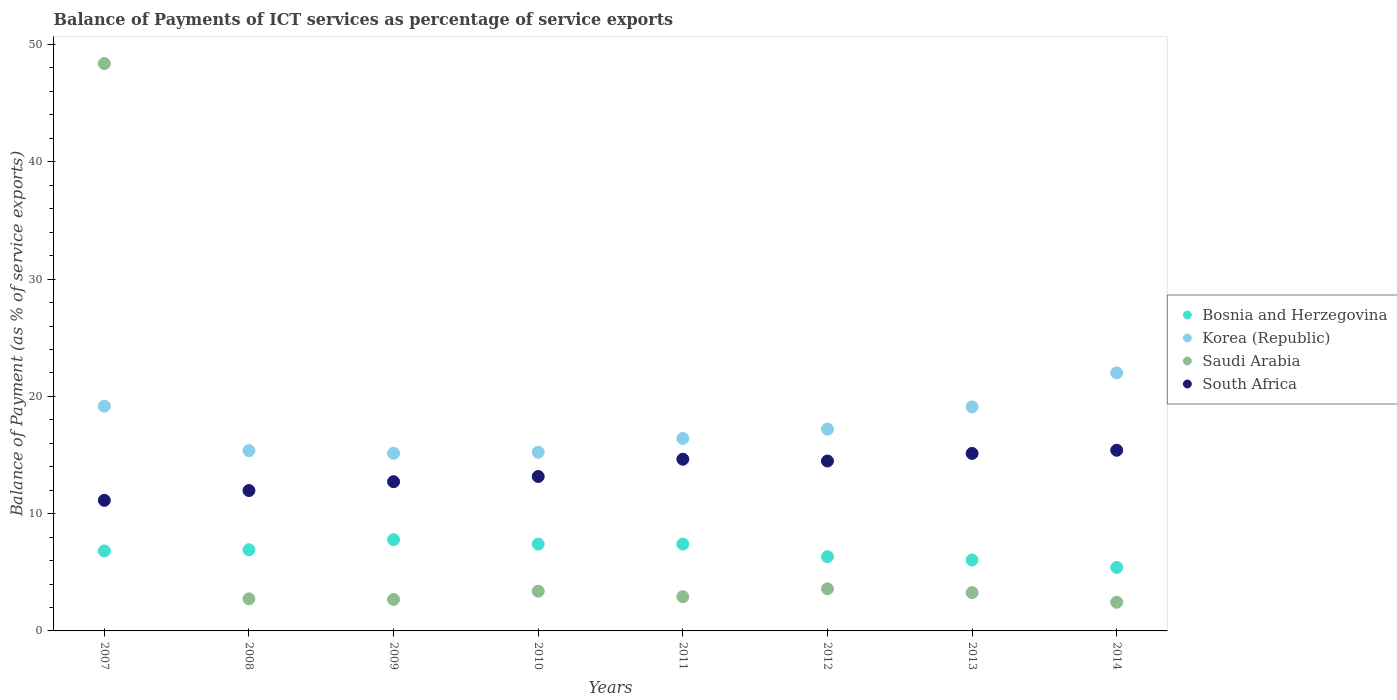What is the balance of payments of ICT services in Bosnia and Herzegovina in 2013?
Your answer should be compact. 6.05. Across all years, what is the maximum balance of payments of ICT services in Korea (Republic)?
Your answer should be compact. 22.01. Across all years, what is the minimum balance of payments of ICT services in Saudi Arabia?
Provide a short and direct response. 2.44. In which year was the balance of payments of ICT services in South Africa minimum?
Offer a very short reply. 2007. What is the total balance of payments of ICT services in Bosnia and Herzegovina in the graph?
Your response must be concise. 54.12. What is the difference between the balance of payments of ICT services in South Africa in 2008 and that in 2011?
Your response must be concise. -2.67. What is the difference between the balance of payments of ICT services in South Africa in 2013 and the balance of payments of ICT services in Saudi Arabia in 2007?
Your response must be concise. -33.25. What is the average balance of payments of ICT services in Korea (Republic) per year?
Make the answer very short. 17.46. In the year 2010, what is the difference between the balance of payments of ICT services in Korea (Republic) and balance of payments of ICT services in Bosnia and Herzegovina?
Offer a very short reply. 7.83. What is the ratio of the balance of payments of ICT services in South Africa in 2013 to that in 2014?
Make the answer very short. 0.98. Is the difference between the balance of payments of ICT services in Korea (Republic) in 2012 and 2013 greater than the difference between the balance of payments of ICT services in Bosnia and Herzegovina in 2012 and 2013?
Keep it short and to the point. No. What is the difference between the highest and the second highest balance of payments of ICT services in Bosnia and Herzegovina?
Provide a succinct answer. 0.37. What is the difference between the highest and the lowest balance of payments of ICT services in Bosnia and Herzegovina?
Provide a short and direct response. 2.36. Is it the case that in every year, the sum of the balance of payments of ICT services in South Africa and balance of payments of ICT services in Korea (Republic)  is greater than the balance of payments of ICT services in Saudi Arabia?
Your response must be concise. No. Is the balance of payments of ICT services in Korea (Republic) strictly greater than the balance of payments of ICT services in Bosnia and Herzegovina over the years?
Your response must be concise. Yes. How many years are there in the graph?
Provide a succinct answer. 8. What is the difference between two consecutive major ticks on the Y-axis?
Keep it short and to the point. 10. Does the graph contain any zero values?
Make the answer very short. No. Where does the legend appear in the graph?
Give a very brief answer. Center right. How many legend labels are there?
Your answer should be very brief. 4. What is the title of the graph?
Your answer should be very brief. Balance of Payments of ICT services as percentage of service exports. Does "Norway" appear as one of the legend labels in the graph?
Give a very brief answer. No. What is the label or title of the X-axis?
Ensure brevity in your answer.  Years. What is the label or title of the Y-axis?
Your answer should be very brief. Balance of Payment (as % of service exports). What is the Balance of Payment (as % of service exports) of Bosnia and Herzegovina in 2007?
Offer a very short reply. 6.82. What is the Balance of Payment (as % of service exports) in Korea (Republic) in 2007?
Give a very brief answer. 19.16. What is the Balance of Payment (as % of service exports) of Saudi Arabia in 2007?
Provide a short and direct response. 48.38. What is the Balance of Payment (as % of service exports) of South Africa in 2007?
Offer a terse response. 11.13. What is the Balance of Payment (as % of service exports) in Bosnia and Herzegovina in 2008?
Make the answer very short. 6.92. What is the Balance of Payment (as % of service exports) in Korea (Republic) in 2008?
Keep it short and to the point. 15.37. What is the Balance of Payment (as % of service exports) of Saudi Arabia in 2008?
Keep it short and to the point. 2.73. What is the Balance of Payment (as % of service exports) of South Africa in 2008?
Make the answer very short. 11.97. What is the Balance of Payment (as % of service exports) of Bosnia and Herzegovina in 2009?
Offer a terse response. 7.78. What is the Balance of Payment (as % of service exports) of Korea (Republic) in 2009?
Give a very brief answer. 15.15. What is the Balance of Payment (as % of service exports) of Saudi Arabia in 2009?
Make the answer very short. 2.68. What is the Balance of Payment (as % of service exports) in South Africa in 2009?
Your answer should be very brief. 12.72. What is the Balance of Payment (as % of service exports) of Bosnia and Herzegovina in 2010?
Ensure brevity in your answer.  7.41. What is the Balance of Payment (as % of service exports) in Korea (Republic) in 2010?
Your response must be concise. 15.24. What is the Balance of Payment (as % of service exports) in Saudi Arabia in 2010?
Give a very brief answer. 3.39. What is the Balance of Payment (as % of service exports) in South Africa in 2010?
Your answer should be very brief. 13.17. What is the Balance of Payment (as % of service exports) in Bosnia and Herzegovina in 2011?
Ensure brevity in your answer.  7.4. What is the Balance of Payment (as % of service exports) in Korea (Republic) in 2011?
Ensure brevity in your answer.  16.41. What is the Balance of Payment (as % of service exports) of Saudi Arabia in 2011?
Make the answer very short. 2.92. What is the Balance of Payment (as % of service exports) in South Africa in 2011?
Offer a very short reply. 14.64. What is the Balance of Payment (as % of service exports) of Bosnia and Herzegovina in 2012?
Provide a succinct answer. 6.33. What is the Balance of Payment (as % of service exports) of Korea (Republic) in 2012?
Make the answer very short. 17.21. What is the Balance of Payment (as % of service exports) of Saudi Arabia in 2012?
Your answer should be compact. 3.59. What is the Balance of Payment (as % of service exports) in South Africa in 2012?
Your answer should be very brief. 14.49. What is the Balance of Payment (as % of service exports) of Bosnia and Herzegovina in 2013?
Keep it short and to the point. 6.05. What is the Balance of Payment (as % of service exports) of Korea (Republic) in 2013?
Keep it short and to the point. 19.1. What is the Balance of Payment (as % of service exports) in Saudi Arabia in 2013?
Keep it short and to the point. 3.26. What is the Balance of Payment (as % of service exports) in South Africa in 2013?
Offer a terse response. 15.13. What is the Balance of Payment (as % of service exports) in Bosnia and Herzegovina in 2014?
Provide a succinct answer. 5.41. What is the Balance of Payment (as % of service exports) of Korea (Republic) in 2014?
Ensure brevity in your answer.  22.01. What is the Balance of Payment (as % of service exports) in Saudi Arabia in 2014?
Give a very brief answer. 2.44. What is the Balance of Payment (as % of service exports) in South Africa in 2014?
Provide a short and direct response. 15.41. Across all years, what is the maximum Balance of Payment (as % of service exports) in Bosnia and Herzegovina?
Offer a very short reply. 7.78. Across all years, what is the maximum Balance of Payment (as % of service exports) of Korea (Republic)?
Your answer should be compact. 22.01. Across all years, what is the maximum Balance of Payment (as % of service exports) in Saudi Arabia?
Offer a very short reply. 48.38. Across all years, what is the maximum Balance of Payment (as % of service exports) in South Africa?
Ensure brevity in your answer.  15.41. Across all years, what is the minimum Balance of Payment (as % of service exports) in Bosnia and Herzegovina?
Provide a succinct answer. 5.41. Across all years, what is the minimum Balance of Payment (as % of service exports) of Korea (Republic)?
Your answer should be compact. 15.15. Across all years, what is the minimum Balance of Payment (as % of service exports) of Saudi Arabia?
Keep it short and to the point. 2.44. Across all years, what is the minimum Balance of Payment (as % of service exports) of South Africa?
Provide a short and direct response. 11.13. What is the total Balance of Payment (as % of service exports) of Bosnia and Herzegovina in the graph?
Your response must be concise. 54.12. What is the total Balance of Payment (as % of service exports) of Korea (Republic) in the graph?
Offer a very short reply. 139.65. What is the total Balance of Payment (as % of service exports) in Saudi Arabia in the graph?
Provide a succinct answer. 69.4. What is the total Balance of Payment (as % of service exports) in South Africa in the graph?
Keep it short and to the point. 108.67. What is the difference between the Balance of Payment (as % of service exports) in Bosnia and Herzegovina in 2007 and that in 2008?
Your answer should be compact. -0.1. What is the difference between the Balance of Payment (as % of service exports) in Korea (Republic) in 2007 and that in 2008?
Offer a terse response. 3.79. What is the difference between the Balance of Payment (as % of service exports) in Saudi Arabia in 2007 and that in 2008?
Ensure brevity in your answer.  45.65. What is the difference between the Balance of Payment (as % of service exports) in South Africa in 2007 and that in 2008?
Offer a terse response. -0.84. What is the difference between the Balance of Payment (as % of service exports) in Bosnia and Herzegovina in 2007 and that in 2009?
Give a very brief answer. -0.95. What is the difference between the Balance of Payment (as % of service exports) of Korea (Republic) in 2007 and that in 2009?
Offer a very short reply. 4.02. What is the difference between the Balance of Payment (as % of service exports) of Saudi Arabia in 2007 and that in 2009?
Offer a terse response. 45.7. What is the difference between the Balance of Payment (as % of service exports) of South Africa in 2007 and that in 2009?
Offer a very short reply. -1.59. What is the difference between the Balance of Payment (as % of service exports) in Bosnia and Herzegovina in 2007 and that in 2010?
Give a very brief answer. -0.58. What is the difference between the Balance of Payment (as % of service exports) of Korea (Republic) in 2007 and that in 2010?
Your response must be concise. 3.93. What is the difference between the Balance of Payment (as % of service exports) of Saudi Arabia in 2007 and that in 2010?
Make the answer very short. 45. What is the difference between the Balance of Payment (as % of service exports) of South Africa in 2007 and that in 2010?
Your answer should be very brief. -2.03. What is the difference between the Balance of Payment (as % of service exports) in Bosnia and Herzegovina in 2007 and that in 2011?
Your answer should be very brief. -0.58. What is the difference between the Balance of Payment (as % of service exports) in Korea (Republic) in 2007 and that in 2011?
Offer a terse response. 2.76. What is the difference between the Balance of Payment (as % of service exports) in Saudi Arabia in 2007 and that in 2011?
Offer a very short reply. 45.47. What is the difference between the Balance of Payment (as % of service exports) in South Africa in 2007 and that in 2011?
Offer a terse response. -3.51. What is the difference between the Balance of Payment (as % of service exports) of Bosnia and Herzegovina in 2007 and that in 2012?
Your answer should be compact. 0.49. What is the difference between the Balance of Payment (as % of service exports) of Korea (Republic) in 2007 and that in 2012?
Give a very brief answer. 1.96. What is the difference between the Balance of Payment (as % of service exports) in Saudi Arabia in 2007 and that in 2012?
Your answer should be very brief. 44.79. What is the difference between the Balance of Payment (as % of service exports) of South Africa in 2007 and that in 2012?
Your answer should be compact. -3.36. What is the difference between the Balance of Payment (as % of service exports) in Bosnia and Herzegovina in 2007 and that in 2013?
Your answer should be compact. 0.77. What is the difference between the Balance of Payment (as % of service exports) of Korea (Republic) in 2007 and that in 2013?
Provide a succinct answer. 0.06. What is the difference between the Balance of Payment (as % of service exports) of Saudi Arabia in 2007 and that in 2013?
Offer a very short reply. 45.12. What is the difference between the Balance of Payment (as % of service exports) of South Africa in 2007 and that in 2013?
Offer a very short reply. -4. What is the difference between the Balance of Payment (as % of service exports) of Bosnia and Herzegovina in 2007 and that in 2014?
Your answer should be very brief. 1.41. What is the difference between the Balance of Payment (as % of service exports) in Korea (Republic) in 2007 and that in 2014?
Your response must be concise. -2.84. What is the difference between the Balance of Payment (as % of service exports) of Saudi Arabia in 2007 and that in 2014?
Ensure brevity in your answer.  45.94. What is the difference between the Balance of Payment (as % of service exports) of South Africa in 2007 and that in 2014?
Offer a terse response. -4.27. What is the difference between the Balance of Payment (as % of service exports) in Bosnia and Herzegovina in 2008 and that in 2009?
Give a very brief answer. -0.85. What is the difference between the Balance of Payment (as % of service exports) of Korea (Republic) in 2008 and that in 2009?
Make the answer very short. 0.23. What is the difference between the Balance of Payment (as % of service exports) in Saudi Arabia in 2008 and that in 2009?
Your response must be concise. 0.05. What is the difference between the Balance of Payment (as % of service exports) in South Africa in 2008 and that in 2009?
Your response must be concise. -0.75. What is the difference between the Balance of Payment (as % of service exports) of Bosnia and Herzegovina in 2008 and that in 2010?
Provide a short and direct response. -0.49. What is the difference between the Balance of Payment (as % of service exports) in Korea (Republic) in 2008 and that in 2010?
Offer a very short reply. 0.14. What is the difference between the Balance of Payment (as % of service exports) of Saudi Arabia in 2008 and that in 2010?
Make the answer very short. -0.65. What is the difference between the Balance of Payment (as % of service exports) of South Africa in 2008 and that in 2010?
Give a very brief answer. -1.19. What is the difference between the Balance of Payment (as % of service exports) in Bosnia and Herzegovina in 2008 and that in 2011?
Your answer should be compact. -0.48. What is the difference between the Balance of Payment (as % of service exports) in Korea (Republic) in 2008 and that in 2011?
Offer a terse response. -1.04. What is the difference between the Balance of Payment (as % of service exports) in Saudi Arabia in 2008 and that in 2011?
Your answer should be compact. -0.18. What is the difference between the Balance of Payment (as % of service exports) in South Africa in 2008 and that in 2011?
Your answer should be compact. -2.67. What is the difference between the Balance of Payment (as % of service exports) in Bosnia and Herzegovina in 2008 and that in 2012?
Make the answer very short. 0.59. What is the difference between the Balance of Payment (as % of service exports) of Korea (Republic) in 2008 and that in 2012?
Your answer should be compact. -1.83. What is the difference between the Balance of Payment (as % of service exports) of Saudi Arabia in 2008 and that in 2012?
Your answer should be very brief. -0.86. What is the difference between the Balance of Payment (as % of service exports) in South Africa in 2008 and that in 2012?
Provide a succinct answer. -2.52. What is the difference between the Balance of Payment (as % of service exports) in Bosnia and Herzegovina in 2008 and that in 2013?
Offer a terse response. 0.87. What is the difference between the Balance of Payment (as % of service exports) in Korea (Republic) in 2008 and that in 2013?
Your response must be concise. -3.73. What is the difference between the Balance of Payment (as % of service exports) of Saudi Arabia in 2008 and that in 2013?
Provide a succinct answer. -0.53. What is the difference between the Balance of Payment (as % of service exports) in South Africa in 2008 and that in 2013?
Your answer should be very brief. -3.16. What is the difference between the Balance of Payment (as % of service exports) of Bosnia and Herzegovina in 2008 and that in 2014?
Offer a very short reply. 1.51. What is the difference between the Balance of Payment (as % of service exports) of Korea (Republic) in 2008 and that in 2014?
Offer a terse response. -6.63. What is the difference between the Balance of Payment (as % of service exports) of Saudi Arabia in 2008 and that in 2014?
Ensure brevity in your answer.  0.29. What is the difference between the Balance of Payment (as % of service exports) in South Africa in 2008 and that in 2014?
Your answer should be very brief. -3.43. What is the difference between the Balance of Payment (as % of service exports) in Bosnia and Herzegovina in 2009 and that in 2010?
Keep it short and to the point. 0.37. What is the difference between the Balance of Payment (as % of service exports) of Korea (Republic) in 2009 and that in 2010?
Give a very brief answer. -0.09. What is the difference between the Balance of Payment (as % of service exports) in Saudi Arabia in 2009 and that in 2010?
Offer a very short reply. -0.7. What is the difference between the Balance of Payment (as % of service exports) in South Africa in 2009 and that in 2010?
Make the answer very short. -0.44. What is the difference between the Balance of Payment (as % of service exports) of Bosnia and Herzegovina in 2009 and that in 2011?
Your answer should be very brief. 0.37. What is the difference between the Balance of Payment (as % of service exports) of Korea (Republic) in 2009 and that in 2011?
Your answer should be compact. -1.26. What is the difference between the Balance of Payment (as % of service exports) of Saudi Arabia in 2009 and that in 2011?
Your answer should be very brief. -0.23. What is the difference between the Balance of Payment (as % of service exports) of South Africa in 2009 and that in 2011?
Keep it short and to the point. -1.92. What is the difference between the Balance of Payment (as % of service exports) of Bosnia and Herzegovina in 2009 and that in 2012?
Your answer should be compact. 1.45. What is the difference between the Balance of Payment (as % of service exports) in Korea (Republic) in 2009 and that in 2012?
Give a very brief answer. -2.06. What is the difference between the Balance of Payment (as % of service exports) in Saudi Arabia in 2009 and that in 2012?
Keep it short and to the point. -0.91. What is the difference between the Balance of Payment (as % of service exports) of South Africa in 2009 and that in 2012?
Your response must be concise. -1.76. What is the difference between the Balance of Payment (as % of service exports) in Bosnia and Herzegovina in 2009 and that in 2013?
Your answer should be compact. 1.73. What is the difference between the Balance of Payment (as % of service exports) of Korea (Republic) in 2009 and that in 2013?
Make the answer very short. -3.96. What is the difference between the Balance of Payment (as % of service exports) in Saudi Arabia in 2009 and that in 2013?
Provide a short and direct response. -0.58. What is the difference between the Balance of Payment (as % of service exports) in South Africa in 2009 and that in 2013?
Make the answer very short. -2.41. What is the difference between the Balance of Payment (as % of service exports) in Bosnia and Herzegovina in 2009 and that in 2014?
Your response must be concise. 2.36. What is the difference between the Balance of Payment (as % of service exports) in Korea (Republic) in 2009 and that in 2014?
Give a very brief answer. -6.86. What is the difference between the Balance of Payment (as % of service exports) of Saudi Arabia in 2009 and that in 2014?
Give a very brief answer. 0.24. What is the difference between the Balance of Payment (as % of service exports) in South Africa in 2009 and that in 2014?
Your answer should be compact. -2.68. What is the difference between the Balance of Payment (as % of service exports) of Bosnia and Herzegovina in 2010 and that in 2011?
Offer a terse response. 0. What is the difference between the Balance of Payment (as % of service exports) in Korea (Republic) in 2010 and that in 2011?
Provide a short and direct response. -1.17. What is the difference between the Balance of Payment (as % of service exports) of Saudi Arabia in 2010 and that in 2011?
Make the answer very short. 0.47. What is the difference between the Balance of Payment (as % of service exports) in South Africa in 2010 and that in 2011?
Your answer should be very brief. -1.47. What is the difference between the Balance of Payment (as % of service exports) in Bosnia and Herzegovina in 2010 and that in 2012?
Keep it short and to the point. 1.08. What is the difference between the Balance of Payment (as % of service exports) in Korea (Republic) in 2010 and that in 2012?
Keep it short and to the point. -1.97. What is the difference between the Balance of Payment (as % of service exports) of Saudi Arabia in 2010 and that in 2012?
Offer a terse response. -0.2. What is the difference between the Balance of Payment (as % of service exports) of South Africa in 2010 and that in 2012?
Offer a very short reply. -1.32. What is the difference between the Balance of Payment (as % of service exports) of Bosnia and Herzegovina in 2010 and that in 2013?
Make the answer very short. 1.36. What is the difference between the Balance of Payment (as % of service exports) of Korea (Republic) in 2010 and that in 2013?
Make the answer very short. -3.87. What is the difference between the Balance of Payment (as % of service exports) of Saudi Arabia in 2010 and that in 2013?
Your answer should be very brief. 0.12. What is the difference between the Balance of Payment (as % of service exports) in South Africa in 2010 and that in 2013?
Offer a terse response. -1.97. What is the difference between the Balance of Payment (as % of service exports) in Bosnia and Herzegovina in 2010 and that in 2014?
Ensure brevity in your answer.  1.99. What is the difference between the Balance of Payment (as % of service exports) in Korea (Republic) in 2010 and that in 2014?
Provide a succinct answer. -6.77. What is the difference between the Balance of Payment (as % of service exports) in Saudi Arabia in 2010 and that in 2014?
Provide a short and direct response. 0.94. What is the difference between the Balance of Payment (as % of service exports) in South Africa in 2010 and that in 2014?
Your answer should be very brief. -2.24. What is the difference between the Balance of Payment (as % of service exports) in Bosnia and Herzegovina in 2011 and that in 2012?
Offer a terse response. 1.07. What is the difference between the Balance of Payment (as % of service exports) of Korea (Republic) in 2011 and that in 2012?
Provide a short and direct response. -0.8. What is the difference between the Balance of Payment (as % of service exports) in Saudi Arabia in 2011 and that in 2012?
Ensure brevity in your answer.  -0.67. What is the difference between the Balance of Payment (as % of service exports) of South Africa in 2011 and that in 2012?
Your answer should be compact. 0.15. What is the difference between the Balance of Payment (as % of service exports) of Bosnia and Herzegovina in 2011 and that in 2013?
Provide a short and direct response. 1.36. What is the difference between the Balance of Payment (as % of service exports) in Korea (Republic) in 2011 and that in 2013?
Your answer should be very brief. -2.69. What is the difference between the Balance of Payment (as % of service exports) of Saudi Arabia in 2011 and that in 2013?
Give a very brief answer. -0.35. What is the difference between the Balance of Payment (as % of service exports) of South Africa in 2011 and that in 2013?
Make the answer very short. -0.49. What is the difference between the Balance of Payment (as % of service exports) of Bosnia and Herzegovina in 2011 and that in 2014?
Your response must be concise. 1.99. What is the difference between the Balance of Payment (as % of service exports) in Korea (Republic) in 2011 and that in 2014?
Your answer should be very brief. -5.6. What is the difference between the Balance of Payment (as % of service exports) in Saudi Arabia in 2011 and that in 2014?
Keep it short and to the point. 0.47. What is the difference between the Balance of Payment (as % of service exports) in South Africa in 2011 and that in 2014?
Provide a short and direct response. -0.76. What is the difference between the Balance of Payment (as % of service exports) in Bosnia and Herzegovina in 2012 and that in 2013?
Make the answer very short. 0.28. What is the difference between the Balance of Payment (as % of service exports) of Korea (Republic) in 2012 and that in 2013?
Offer a terse response. -1.9. What is the difference between the Balance of Payment (as % of service exports) in Saudi Arabia in 2012 and that in 2013?
Keep it short and to the point. 0.33. What is the difference between the Balance of Payment (as % of service exports) in South Africa in 2012 and that in 2013?
Make the answer very short. -0.65. What is the difference between the Balance of Payment (as % of service exports) of Bosnia and Herzegovina in 2012 and that in 2014?
Offer a very short reply. 0.92. What is the difference between the Balance of Payment (as % of service exports) in Korea (Republic) in 2012 and that in 2014?
Your answer should be very brief. -4.8. What is the difference between the Balance of Payment (as % of service exports) in Saudi Arabia in 2012 and that in 2014?
Ensure brevity in your answer.  1.15. What is the difference between the Balance of Payment (as % of service exports) of South Africa in 2012 and that in 2014?
Ensure brevity in your answer.  -0.92. What is the difference between the Balance of Payment (as % of service exports) in Bosnia and Herzegovina in 2013 and that in 2014?
Provide a short and direct response. 0.63. What is the difference between the Balance of Payment (as % of service exports) of Korea (Republic) in 2013 and that in 2014?
Your answer should be very brief. -2.9. What is the difference between the Balance of Payment (as % of service exports) of Saudi Arabia in 2013 and that in 2014?
Provide a succinct answer. 0.82. What is the difference between the Balance of Payment (as % of service exports) of South Africa in 2013 and that in 2014?
Give a very brief answer. -0.27. What is the difference between the Balance of Payment (as % of service exports) of Bosnia and Herzegovina in 2007 and the Balance of Payment (as % of service exports) of Korea (Republic) in 2008?
Your response must be concise. -8.55. What is the difference between the Balance of Payment (as % of service exports) of Bosnia and Herzegovina in 2007 and the Balance of Payment (as % of service exports) of Saudi Arabia in 2008?
Make the answer very short. 4.09. What is the difference between the Balance of Payment (as % of service exports) of Bosnia and Herzegovina in 2007 and the Balance of Payment (as % of service exports) of South Africa in 2008?
Provide a succinct answer. -5.15. What is the difference between the Balance of Payment (as % of service exports) of Korea (Republic) in 2007 and the Balance of Payment (as % of service exports) of Saudi Arabia in 2008?
Ensure brevity in your answer.  16.43. What is the difference between the Balance of Payment (as % of service exports) in Korea (Republic) in 2007 and the Balance of Payment (as % of service exports) in South Africa in 2008?
Give a very brief answer. 7.19. What is the difference between the Balance of Payment (as % of service exports) in Saudi Arabia in 2007 and the Balance of Payment (as % of service exports) in South Africa in 2008?
Your answer should be compact. 36.41. What is the difference between the Balance of Payment (as % of service exports) in Bosnia and Herzegovina in 2007 and the Balance of Payment (as % of service exports) in Korea (Republic) in 2009?
Ensure brevity in your answer.  -8.33. What is the difference between the Balance of Payment (as % of service exports) of Bosnia and Herzegovina in 2007 and the Balance of Payment (as % of service exports) of Saudi Arabia in 2009?
Ensure brevity in your answer.  4.14. What is the difference between the Balance of Payment (as % of service exports) of Bosnia and Herzegovina in 2007 and the Balance of Payment (as % of service exports) of South Africa in 2009?
Keep it short and to the point. -5.9. What is the difference between the Balance of Payment (as % of service exports) of Korea (Republic) in 2007 and the Balance of Payment (as % of service exports) of Saudi Arabia in 2009?
Keep it short and to the point. 16.48. What is the difference between the Balance of Payment (as % of service exports) in Korea (Republic) in 2007 and the Balance of Payment (as % of service exports) in South Africa in 2009?
Give a very brief answer. 6.44. What is the difference between the Balance of Payment (as % of service exports) in Saudi Arabia in 2007 and the Balance of Payment (as % of service exports) in South Africa in 2009?
Offer a terse response. 35.66. What is the difference between the Balance of Payment (as % of service exports) in Bosnia and Herzegovina in 2007 and the Balance of Payment (as % of service exports) in Korea (Republic) in 2010?
Offer a terse response. -8.42. What is the difference between the Balance of Payment (as % of service exports) in Bosnia and Herzegovina in 2007 and the Balance of Payment (as % of service exports) in Saudi Arabia in 2010?
Your answer should be compact. 3.44. What is the difference between the Balance of Payment (as % of service exports) in Bosnia and Herzegovina in 2007 and the Balance of Payment (as % of service exports) in South Africa in 2010?
Give a very brief answer. -6.34. What is the difference between the Balance of Payment (as % of service exports) in Korea (Republic) in 2007 and the Balance of Payment (as % of service exports) in Saudi Arabia in 2010?
Offer a terse response. 15.78. What is the difference between the Balance of Payment (as % of service exports) in Korea (Republic) in 2007 and the Balance of Payment (as % of service exports) in South Africa in 2010?
Provide a short and direct response. 6. What is the difference between the Balance of Payment (as % of service exports) in Saudi Arabia in 2007 and the Balance of Payment (as % of service exports) in South Africa in 2010?
Make the answer very short. 35.22. What is the difference between the Balance of Payment (as % of service exports) of Bosnia and Herzegovina in 2007 and the Balance of Payment (as % of service exports) of Korea (Republic) in 2011?
Provide a succinct answer. -9.59. What is the difference between the Balance of Payment (as % of service exports) of Bosnia and Herzegovina in 2007 and the Balance of Payment (as % of service exports) of Saudi Arabia in 2011?
Make the answer very short. 3.91. What is the difference between the Balance of Payment (as % of service exports) in Bosnia and Herzegovina in 2007 and the Balance of Payment (as % of service exports) in South Africa in 2011?
Give a very brief answer. -7.82. What is the difference between the Balance of Payment (as % of service exports) of Korea (Republic) in 2007 and the Balance of Payment (as % of service exports) of Saudi Arabia in 2011?
Offer a terse response. 16.25. What is the difference between the Balance of Payment (as % of service exports) of Korea (Republic) in 2007 and the Balance of Payment (as % of service exports) of South Africa in 2011?
Offer a terse response. 4.52. What is the difference between the Balance of Payment (as % of service exports) in Saudi Arabia in 2007 and the Balance of Payment (as % of service exports) in South Africa in 2011?
Provide a succinct answer. 33.74. What is the difference between the Balance of Payment (as % of service exports) in Bosnia and Herzegovina in 2007 and the Balance of Payment (as % of service exports) in Korea (Republic) in 2012?
Offer a terse response. -10.38. What is the difference between the Balance of Payment (as % of service exports) in Bosnia and Herzegovina in 2007 and the Balance of Payment (as % of service exports) in Saudi Arabia in 2012?
Provide a succinct answer. 3.23. What is the difference between the Balance of Payment (as % of service exports) in Bosnia and Herzegovina in 2007 and the Balance of Payment (as % of service exports) in South Africa in 2012?
Ensure brevity in your answer.  -7.67. What is the difference between the Balance of Payment (as % of service exports) in Korea (Republic) in 2007 and the Balance of Payment (as % of service exports) in Saudi Arabia in 2012?
Give a very brief answer. 15.57. What is the difference between the Balance of Payment (as % of service exports) in Korea (Republic) in 2007 and the Balance of Payment (as % of service exports) in South Africa in 2012?
Your response must be concise. 4.68. What is the difference between the Balance of Payment (as % of service exports) in Saudi Arabia in 2007 and the Balance of Payment (as % of service exports) in South Africa in 2012?
Offer a terse response. 33.89. What is the difference between the Balance of Payment (as % of service exports) in Bosnia and Herzegovina in 2007 and the Balance of Payment (as % of service exports) in Korea (Republic) in 2013?
Keep it short and to the point. -12.28. What is the difference between the Balance of Payment (as % of service exports) in Bosnia and Herzegovina in 2007 and the Balance of Payment (as % of service exports) in Saudi Arabia in 2013?
Your response must be concise. 3.56. What is the difference between the Balance of Payment (as % of service exports) in Bosnia and Herzegovina in 2007 and the Balance of Payment (as % of service exports) in South Africa in 2013?
Provide a short and direct response. -8.31. What is the difference between the Balance of Payment (as % of service exports) of Korea (Republic) in 2007 and the Balance of Payment (as % of service exports) of Saudi Arabia in 2013?
Your answer should be very brief. 15.9. What is the difference between the Balance of Payment (as % of service exports) of Korea (Republic) in 2007 and the Balance of Payment (as % of service exports) of South Africa in 2013?
Provide a succinct answer. 4.03. What is the difference between the Balance of Payment (as % of service exports) in Saudi Arabia in 2007 and the Balance of Payment (as % of service exports) in South Africa in 2013?
Provide a succinct answer. 33.25. What is the difference between the Balance of Payment (as % of service exports) in Bosnia and Herzegovina in 2007 and the Balance of Payment (as % of service exports) in Korea (Republic) in 2014?
Your answer should be very brief. -15.18. What is the difference between the Balance of Payment (as % of service exports) of Bosnia and Herzegovina in 2007 and the Balance of Payment (as % of service exports) of Saudi Arabia in 2014?
Give a very brief answer. 4.38. What is the difference between the Balance of Payment (as % of service exports) in Bosnia and Herzegovina in 2007 and the Balance of Payment (as % of service exports) in South Africa in 2014?
Provide a short and direct response. -8.58. What is the difference between the Balance of Payment (as % of service exports) in Korea (Republic) in 2007 and the Balance of Payment (as % of service exports) in Saudi Arabia in 2014?
Your answer should be very brief. 16.72. What is the difference between the Balance of Payment (as % of service exports) of Korea (Republic) in 2007 and the Balance of Payment (as % of service exports) of South Africa in 2014?
Your answer should be compact. 3.76. What is the difference between the Balance of Payment (as % of service exports) of Saudi Arabia in 2007 and the Balance of Payment (as % of service exports) of South Africa in 2014?
Offer a very short reply. 32.98. What is the difference between the Balance of Payment (as % of service exports) of Bosnia and Herzegovina in 2008 and the Balance of Payment (as % of service exports) of Korea (Republic) in 2009?
Offer a terse response. -8.23. What is the difference between the Balance of Payment (as % of service exports) of Bosnia and Herzegovina in 2008 and the Balance of Payment (as % of service exports) of Saudi Arabia in 2009?
Your response must be concise. 4.24. What is the difference between the Balance of Payment (as % of service exports) in Bosnia and Herzegovina in 2008 and the Balance of Payment (as % of service exports) in South Africa in 2009?
Keep it short and to the point. -5.8. What is the difference between the Balance of Payment (as % of service exports) of Korea (Republic) in 2008 and the Balance of Payment (as % of service exports) of Saudi Arabia in 2009?
Your answer should be very brief. 12.69. What is the difference between the Balance of Payment (as % of service exports) of Korea (Republic) in 2008 and the Balance of Payment (as % of service exports) of South Africa in 2009?
Offer a terse response. 2.65. What is the difference between the Balance of Payment (as % of service exports) of Saudi Arabia in 2008 and the Balance of Payment (as % of service exports) of South Africa in 2009?
Your answer should be very brief. -9.99. What is the difference between the Balance of Payment (as % of service exports) of Bosnia and Herzegovina in 2008 and the Balance of Payment (as % of service exports) of Korea (Republic) in 2010?
Make the answer very short. -8.32. What is the difference between the Balance of Payment (as % of service exports) in Bosnia and Herzegovina in 2008 and the Balance of Payment (as % of service exports) in Saudi Arabia in 2010?
Provide a succinct answer. 3.53. What is the difference between the Balance of Payment (as % of service exports) of Bosnia and Herzegovina in 2008 and the Balance of Payment (as % of service exports) of South Africa in 2010?
Provide a short and direct response. -6.25. What is the difference between the Balance of Payment (as % of service exports) in Korea (Republic) in 2008 and the Balance of Payment (as % of service exports) in Saudi Arabia in 2010?
Your answer should be very brief. 11.99. What is the difference between the Balance of Payment (as % of service exports) in Korea (Republic) in 2008 and the Balance of Payment (as % of service exports) in South Africa in 2010?
Your answer should be very brief. 2.21. What is the difference between the Balance of Payment (as % of service exports) of Saudi Arabia in 2008 and the Balance of Payment (as % of service exports) of South Africa in 2010?
Make the answer very short. -10.43. What is the difference between the Balance of Payment (as % of service exports) in Bosnia and Herzegovina in 2008 and the Balance of Payment (as % of service exports) in Korea (Republic) in 2011?
Your answer should be compact. -9.49. What is the difference between the Balance of Payment (as % of service exports) in Bosnia and Herzegovina in 2008 and the Balance of Payment (as % of service exports) in Saudi Arabia in 2011?
Keep it short and to the point. 4.01. What is the difference between the Balance of Payment (as % of service exports) of Bosnia and Herzegovina in 2008 and the Balance of Payment (as % of service exports) of South Africa in 2011?
Ensure brevity in your answer.  -7.72. What is the difference between the Balance of Payment (as % of service exports) in Korea (Republic) in 2008 and the Balance of Payment (as % of service exports) in Saudi Arabia in 2011?
Your response must be concise. 12.46. What is the difference between the Balance of Payment (as % of service exports) in Korea (Republic) in 2008 and the Balance of Payment (as % of service exports) in South Africa in 2011?
Provide a succinct answer. 0.73. What is the difference between the Balance of Payment (as % of service exports) in Saudi Arabia in 2008 and the Balance of Payment (as % of service exports) in South Africa in 2011?
Give a very brief answer. -11.91. What is the difference between the Balance of Payment (as % of service exports) in Bosnia and Herzegovina in 2008 and the Balance of Payment (as % of service exports) in Korea (Republic) in 2012?
Provide a succinct answer. -10.28. What is the difference between the Balance of Payment (as % of service exports) of Bosnia and Herzegovina in 2008 and the Balance of Payment (as % of service exports) of Saudi Arabia in 2012?
Offer a terse response. 3.33. What is the difference between the Balance of Payment (as % of service exports) in Bosnia and Herzegovina in 2008 and the Balance of Payment (as % of service exports) in South Africa in 2012?
Give a very brief answer. -7.57. What is the difference between the Balance of Payment (as % of service exports) in Korea (Republic) in 2008 and the Balance of Payment (as % of service exports) in Saudi Arabia in 2012?
Offer a terse response. 11.78. What is the difference between the Balance of Payment (as % of service exports) in Korea (Republic) in 2008 and the Balance of Payment (as % of service exports) in South Africa in 2012?
Make the answer very short. 0.88. What is the difference between the Balance of Payment (as % of service exports) in Saudi Arabia in 2008 and the Balance of Payment (as % of service exports) in South Africa in 2012?
Ensure brevity in your answer.  -11.75. What is the difference between the Balance of Payment (as % of service exports) in Bosnia and Herzegovina in 2008 and the Balance of Payment (as % of service exports) in Korea (Republic) in 2013?
Keep it short and to the point. -12.18. What is the difference between the Balance of Payment (as % of service exports) of Bosnia and Herzegovina in 2008 and the Balance of Payment (as % of service exports) of Saudi Arabia in 2013?
Keep it short and to the point. 3.66. What is the difference between the Balance of Payment (as % of service exports) in Bosnia and Herzegovina in 2008 and the Balance of Payment (as % of service exports) in South Africa in 2013?
Offer a very short reply. -8.21. What is the difference between the Balance of Payment (as % of service exports) in Korea (Republic) in 2008 and the Balance of Payment (as % of service exports) in Saudi Arabia in 2013?
Provide a short and direct response. 12.11. What is the difference between the Balance of Payment (as % of service exports) in Korea (Republic) in 2008 and the Balance of Payment (as % of service exports) in South Africa in 2013?
Your answer should be very brief. 0.24. What is the difference between the Balance of Payment (as % of service exports) in Saudi Arabia in 2008 and the Balance of Payment (as % of service exports) in South Africa in 2013?
Keep it short and to the point. -12.4. What is the difference between the Balance of Payment (as % of service exports) in Bosnia and Herzegovina in 2008 and the Balance of Payment (as % of service exports) in Korea (Republic) in 2014?
Keep it short and to the point. -15.08. What is the difference between the Balance of Payment (as % of service exports) of Bosnia and Herzegovina in 2008 and the Balance of Payment (as % of service exports) of Saudi Arabia in 2014?
Your answer should be very brief. 4.48. What is the difference between the Balance of Payment (as % of service exports) in Bosnia and Herzegovina in 2008 and the Balance of Payment (as % of service exports) in South Africa in 2014?
Offer a very short reply. -8.48. What is the difference between the Balance of Payment (as % of service exports) of Korea (Republic) in 2008 and the Balance of Payment (as % of service exports) of Saudi Arabia in 2014?
Keep it short and to the point. 12.93. What is the difference between the Balance of Payment (as % of service exports) in Korea (Republic) in 2008 and the Balance of Payment (as % of service exports) in South Africa in 2014?
Ensure brevity in your answer.  -0.03. What is the difference between the Balance of Payment (as % of service exports) of Saudi Arabia in 2008 and the Balance of Payment (as % of service exports) of South Africa in 2014?
Give a very brief answer. -12.67. What is the difference between the Balance of Payment (as % of service exports) in Bosnia and Herzegovina in 2009 and the Balance of Payment (as % of service exports) in Korea (Republic) in 2010?
Provide a short and direct response. -7.46. What is the difference between the Balance of Payment (as % of service exports) of Bosnia and Herzegovina in 2009 and the Balance of Payment (as % of service exports) of Saudi Arabia in 2010?
Ensure brevity in your answer.  4.39. What is the difference between the Balance of Payment (as % of service exports) of Bosnia and Herzegovina in 2009 and the Balance of Payment (as % of service exports) of South Africa in 2010?
Ensure brevity in your answer.  -5.39. What is the difference between the Balance of Payment (as % of service exports) in Korea (Republic) in 2009 and the Balance of Payment (as % of service exports) in Saudi Arabia in 2010?
Ensure brevity in your answer.  11.76. What is the difference between the Balance of Payment (as % of service exports) in Korea (Republic) in 2009 and the Balance of Payment (as % of service exports) in South Africa in 2010?
Your response must be concise. 1.98. What is the difference between the Balance of Payment (as % of service exports) in Saudi Arabia in 2009 and the Balance of Payment (as % of service exports) in South Africa in 2010?
Ensure brevity in your answer.  -10.48. What is the difference between the Balance of Payment (as % of service exports) of Bosnia and Herzegovina in 2009 and the Balance of Payment (as % of service exports) of Korea (Republic) in 2011?
Ensure brevity in your answer.  -8.63. What is the difference between the Balance of Payment (as % of service exports) of Bosnia and Herzegovina in 2009 and the Balance of Payment (as % of service exports) of Saudi Arabia in 2011?
Offer a very short reply. 4.86. What is the difference between the Balance of Payment (as % of service exports) of Bosnia and Herzegovina in 2009 and the Balance of Payment (as % of service exports) of South Africa in 2011?
Offer a terse response. -6.87. What is the difference between the Balance of Payment (as % of service exports) in Korea (Republic) in 2009 and the Balance of Payment (as % of service exports) in Saudi Arabia in 2011?
Provide a short and direct response. 12.23. What is the difference between the Balance of Payment (as % of service exports) in Korea (Republic) in 2009 and the Balance of Payment (as % of service exports) in South Africa in 2011?
Your response must be concise. 0.51. What is the difference between the Balance of Payment (as % of service exports) of Saudi Arabia in 2009 and the Balance of Payment (as % of service exports) of South Africa in 2011?
Provide a short and direct response. -11.96. What is the difference between the Balance of Payment (as % of service exports) in Bosnia and Herzegovina in 2009 and the Balance of Payment (as % of service exports) in Korea (Republic) in 2012?
Offer a very short reply. -9.43. What is the difference between the Balance of Payment (as % of service exports) in Bosnia and Herzegovina in 2009 and the Balance of Payment (as % of service exports) in Saudi Arabia in 2012?
Offer a terse response. 4.19. What is the difference between the Balance of Payment (as % of service exports) of Bosnia and Herzegovina in 2009 and the Balance of Payment (as % of service exports) of South Africa in 2012?
Provide a short and direct response. -6.71. What is the difference between the Balance of Payment (as % of service exports) in Korea (Republic) in 2009 and the Balance of Payment (as % of service exports) in Saudi Arabia in 2012?
Your answer should be compact. 11.56. What is the difference between the Balance of Payment (as % of service exports) of Korea (Republic) in 2009 and the Balance of Payment (as % of service exports) of South Africa in 2012?
Make the answer very short. 0.66. What is the difference between the Balance of Payment (as % of service exports) of Saudi Arabia in 2009 and the Balance of Payment (as % of service exports) of South Africa in 2012?
Make the answer very short. -11.8. What is the difference between the Balance of Payment (as % of service exports) of Bosnia and Herzegovina in 2009 and the Balance of Payment (as % of service exports) of Korea (Republic) in 2013?
Keep it short and to the point. -11.33. What is the difference between the Balance of Payment (as % of service exports) of Bosnia and Herzegovina in 2009 and the Balance of Payment (as % of service exports) of Saudi Arabia in 2013?
Your response must be concise. 4.51. What is the difference between the Balance of Payment (as % of service exports) of Bosnia and Herzegovina in 2009 and the Balance of Payment (as % of service exports) of South Africa in 2013?
Your response must be concise. -7.36. What is the difference between the Balance of Payment (as % of service exports) of Korea (Republic) in 2009 and the Balance of Payment (as % of service exports) of Saudi Arabia in 2013?
Provide a short and direct response. 11.88. What is the difference between the Balance of Payment (as % of service exports) of Korea (Republic) in 2009 and the Balance of Payment (as % of service exports) of South Africa in 2013?
Ensure brevity in your answer.  0.01. What is the difference between the Balance of Payment (as % of service exports) of Saudi Arabia in 2009 and the Balance of Payment (as % of service exports) of South Africa in 2013?
Keep it short and to the point. -12.45. What is the difference between the Balance of Payment (as % of service exports) in Bosnia and Herzegovina in 2009 and the Balance of Payment (as % of service exports) in Korea (Republic) in 2014?
Give a very brief answer. -14.23. What is the difference between the Balance of Payment (as % of service exports) in Bosnia and Herzegovina in 2009 and the Balance of Payment (as % of service exports) in Saudi Arabia in 2014?
Provide a short and direct response. 5.33. What is the difference between the Balance of Payment (as % of service exports) in Bosnia and Herzegovina in 2009 and the Balance of Payment (as % of service exports) in South Africa in 2014?
Ensure brevity in your answer.  -7.63. What is the difference between the Balance of Payment (as % of service exports) of Korea (Republic) in 2009 and the Balance of Payment (as % of service exports) of Saudi Arabia in 2014?
Give a very brief answer. 12.7. What is the difference between the Balance of Payment (as % of service exports) of Korea (Republic) in 2009 and the Balance of Payment (as % of service exports) of South Africa in 2014?
Keep it short and to the point. -0.26. What is the difference between the Balance of Payment (as % of service exports) of Saudi Arabia in 2009 and the Balance of Payment (as % of service exports) of South Africa in 2014?
Offer a very short reply. -12.72. What is the difference between the Balance of Payment (as % of service exports) of Bosnia and Herzegovina in 2010 and the Balance of Payment (as % of service exports) of Korea (Republic) in 2011?
Keep it short and to the point. -9. What is the difference between the Balance of Payment (as % of service exports) in Bosnia and Herzegovina in 2010 and the Balance of Payment (as % of service exports) in Saudi Arabia in 2011?
Make the answer very short. 4.49. What is the difference between the Balance of Payment (as % of service exports) of Bosnia and Herzegovina in 2010 and the Balance of Payment (as % of service exports) of South Africa in 2011?
Keep it short and to the point. -7.23. What is the difference between the Balance of Payment (as % of service exports) of Korea (Republic) in 2010 and the Balance of Payment (as % of service exports) of Saudi Arabia in 2011?
Your answer should be compact. 12.32. What is the difference between the Balance of Payment (as % of service exports) of Korea (Republic) in 2010 and the Balance of Payment (as % of service exports) of South Africa in 2011?
Make the answer very short. 0.6. What is the difference between the Balance of Payment (as % of service exports) of Saudi Arabia in 2010 and the Balance of Payment (as % of service exports) of South Africa in 2011?
Offer a terse response. -11.25. What is the difference between the Balance of Payment (as % of service exports) in Bosnia and Herzegovina in 2010 and the Balance of Payment (as % of service exports) in Korea (Republic) in 2012?
Give a very brief answer. -9.8. What is the difference between the Balance of Payment (as % of service exports) in Bosnia and Herzegovina in 2010 and the Balance of Payment (as % of service exports) in Saudi Arabia in 2012?
Offer a very short reply. 3.82. What is the difference between the Balance of Payment (as % of service exports) of Bosnia and Herzegovina in 2010 and the Balance of Payment (as % of service exports) of South Africa in 2012?
Your response must be concise. -7.08. What is the difference between the Balance of Payment (as % of service exports) of Korea (Republic) in 2010 and the Balance of Payment (as % of service exports) of Saudi Arabia in 2012?
Give a very brief answer. 11.65. What is the difference between the Balance of Payment (as % of service exports) in Korea (Republic) in 2010 and the Balance of Payment (as % of service exports) in South Africa in 2012?
Your response must be concise. 0.75. What is the difference between the Balance of Payment (as % of service exports) in Saudi Arabia in 2010 and the Balance of Payment (as % of service exports) in South Africa in 2012?
Your answer should be very brief. -11.1. What is the difference between the Balance of Payment (as % of service exports) of Bosnia and Herzegovina in 2010 and the Balance of Payment (as % of service exports) of Korea (Republic) in 2013?
Ensure brevity in your answer.  -11.7. What is the difference between the Balance of Payment (as % of service exports) in Bosnia and Herzegovina in 2010 and the Balance of Payment (as % of service exports) in Saudi Arabia in 2013?
Offer a very short reply. 4.14. What is the difference between the Balance of Payment (as % of service exports) of Bosnia and Herzegovina in 2010 and the Balance of Payment (as % of service exports) of South Africa in 2013?
Your answer should be compact. -7.73. What is the difference between the Balance of Payment (as % of service exports) of Korea (Republic) in 2010 and the Balance of Payment (as % of service exports) of Saudi Arabia in 2013?
Ensure brevity in your answer.  11.97. What is the difference between the Balance of Payment (as % of service exports) in Korea (Republic) in 2010 and the Balance of Payment (as % of service exports) in South Africa in 2013?
Your answer should be compact. 0.1. What is the difference between the Balance of Payment (as % of service exports) of Saudi Arabia in 2010 and the Balance of Payment (as % of service exports) of South Africa in 2013?
Offer a very short reply. -11.75. What is the difference between the Balance of Payment (as % of service exports) of Bosnia and Herzegovina in 2010 and the Balance of Payment (as % of service exports) of Korea (Republic) in 2014?
Provide a succinct answer. -14.6. What is the difference between the Balance of Payment (as % of service exports) in Bosnia and Herzegovina in 2010 and the Balance of Payment (as % of service exports) in Saudi Arabia in 2014?
Your response must be concise. 4.96. What is the difference between the Balance of Payment (as % of service exports) of Bosnia and Herzegovina in 2010 and the Balance of Payment (as % of service exports) of South Africa in 2014?
Your response must be concise. -8. What is the difference between the Balance of Payment (as % of service exports) of Korea (Republic) in 2010 and the Balance of Payment (as % of service exports) of Saudi Arabia in 2014?
Provide a succinct answer. 12.79. What is the difference between the Balance of Payment (as % of service exports) of Korea (Republic) in 2010 and the Balance of Payment (as % of service exports) of South Africa in 2014?
Offer a terse response. -0.17. What is the difference between the Balance of Payment (as % of service exports) in Saudi Arabia in 2010 and the Balance of Payment (as % of service exports) in South Africa in 2014?
Provide a short and direct response. -12.02. What is the difference between the Balance of Payment (as % of service exports) in Bosnia and Herzegovina in 2011 and the Balance of Payment (as % of service exports) in Korea (Republic) in 2012?
Your response must be concise. -9.8. What is the difference between the Balance of Payment (as % of service exports) of Bosnia and Herzegovina in 2011 and the Balance of Payment (as % of service exports) of Saudi Arabia in 2012?
Offer a terse response. 3.81. What is the difference between the Balance of Payment (as % of service exports) in Bosnia and Herzegovina in 2011 and the Balance of Payment (as % of service exports) in South Africa in 2012?
Provide a succinct answer. -7.08. What is the difference between the Balance of Payment (as % of service exports) of Korea (Republic) in 2011 and the Balance of Payment (as % of service exports) of Saudi Arabia in 2012?
Ensure brevity in your answer.  12.82. What is the difference between the Balance of Payment (as % of service exports) in Korea (Republic) in 2011 and the Balance of Payment (as % of service exports) in South Africa in 2012?
Give a very brief answer. 1.92. What is the difference between the Balance of Payment (as % of service exports) of Saudi Arabia in 2011 and the Balance of Payment (as % of service exports) of South Africa in 2012?
Keep it short and to the point. -11.57. What is the difference between the Balance of Payment (as % of service exports) in Bosnia and Herzegovina in 2011 and the Balance of Payment (as % of service exports) in Korea (Republic) in 2013?
Your answer should be very brief. -11.7. What is the difference between the Balance of Payment (as % of service exports) in Bosnia and Herzegovina in 2011 and the Balance of Payment (as % of service exports) in Saudi Arabia in 2013?
Ensure brevity in your answer.  4.14. What is the difference between the Balance of Payment (as % of service exports) in Bosnia and Herzegovina in 2011 and the Balance of Payment (as % of service exports) in South Africa in 2013?
Give a very brief answer. -7.73. What is the difference between the Balance of Payment (as % of service exports) of Korea (Republic) in 2011 and the Balance of Payment (as % of service exports) of Saudi Arabia in 2013?
Your response must be concise. 13.15. What is the difference between the Balance of Payment (as % of service exports) of Korea (Republic) in 2011 and the Balance of Payment (as % of service exports) of South Africa in 2013?
Keep it short and to the point. 1.28. What is the difference between the Balance of Payment (as % of service exports) in Saudi Arabia in 2011 and the Balance of Payment (as % of service exports) in South Africa in 2013?
Make the answer very short. -12.22. What is the difference between the Balance of Payment (as % of service exports) in Bosnia and Herzegovina in 2011 and the Balance of Payment (as % of service exports) in Korea (Republic) in 2014?
Provide a short and direct response. -14.6. What is the difference between the Balance of Payment (as % of service exports) in Bosnia and Herzegovina in 2011 and the Balance of Payment (as % of service exports) in Saudi Arabia in 2014?
Your answer should be very brief. 4.96. What is the difference between the Balance of Payment (as % of service exports) of Bosnia and Herzegovina in 2011 and the Balance of Payment (as % of service exports) of South Africa in 2014?
Give a very brief answer. -8. What is the difference between the Balance of Payment (as % of service exports) in Korea (Republic) in 2011 and the Balance of Payment (as % of service exports) in Saudi Arabia in 2014?
Make the answer very short. 13.97. What is the difference between the Balance of Payment (as % of service exports) in Korea (Republic) in 2011 and the Balance of Payment (as % of service exports) in South Africa in 2014?
Your response must be concise. 1. What is the difference between the Balance of Payment (as % of service exports) of Saudi Arabia in 2011 and the Balance of Payment (as % of service exports) of South Africa in 2014?
Keep it short and to the point. -12.49. What is the difference between the Balance of Payment (as % of service exports) in Bosnia and Herzegovina in 2012 and the Balance of Payment (as % of service exports) in Korea (Republic) in 2013?
Offer a very short reply. -12.77. What is the difference between the Balance of Payment (as % of service exports) in Bosnia and Herzegovina in 2012 and the Balance of Payment (as % of service exports) in Saudi Arabia in 2013?
Your answer should be compact. 3.07. What is the difference between the Balance of Payment (as % of service exports) in Bosnia and Herzegovina in 2012 and the Balance of Payment (as % of service exports) in South Africa in 2013?
Ensure brevity in your answer.  -8.8. What is the difference between the Balance of Payment (as % of service exports) in Korea (Republic) in 2012 and the Balance of Payment (as % of service exports) in Saudi Arabia in 2013?
Give a very brief answer. 13.94. What is the difference between the Balance of Payment (as % of service exports) of Korea (Republic) in 2012 and the Balance of Payment (as % of service exports) of South Africa in 2013?
Provide a succinct answer. 2.07. What is the difference between the Balance of Payment (as % of service exports) of Saudi Arabia in 2012 and the Balance of Payment (as % of service exports) of South Africa in 2013?
Your answer should be very brief. -11.54. What is the difference between the Balance of Payment (as % of service exports) in Bosnia and Herzegovina in 2012 and the Balance of Payment (as % of service exports) in Korea (Republic) in 2014?
Offer a terse response. -15.68. What is the difference between the Balance of Payment (as % of service exports) in Bosnia and Herzegovina in 2012 and the Balance of Payment (as % of service exports) in Saudi Arabia in 2014?
Offer a terse response. 3.89. What is the difference between the Balance of Payment (as % of service exports) of Bosnia and Herzegovina in 2012 and the Balance of Payment (as % of service exports) of South Africa in 2014?
Provide a succinct answer. -9.08. What is the difference between the Balance of Payment (as % of service exports) of Korea (Republic) in 2012 and the Balance of Payment (as % of service exports) of Saudi Arabia in 2014?
Your answer should be very brief. 14.76. What is the difference between the Balance of Payment (as % of service exports) in Korea (Republic) in 2012 and the Balance of Payment (as % of service exports) in South Africa in 2014?
Your response must be concise. 1.8. What is the difference between the Balance of Payment (as % of service exports) of Saudi Arabia in 2012 and the Balance of Payment (as % of service exports) of South Africa in 2014?
Provide a succinct answer. -11.82. What is the difference between the Balance of Payment (as % of service exports) of Bosnia and Herzegovina in 2013 and the Balance of Payment (as % of service exports) of Korea (Republic) in 2014?
Provide a short and direct response. -15.96. What is the difference between the Balance of Payment (as % of service exports) of Bosnia and Herzegovina in 2013 and the Balance of Payment (as % of service exports) of Saudi Arabia in 2014?
Provide a short and direct response. 3.6. What is the difference between the Balance of Payment (as % of service exports) in Bosnia and Herzegovina in 2013 and the Balance of Payment (as % of service exports) in South Africa in 2014?
Your answer should be compact. -9.36. What is the difference between the Balance of Payment (as % of service exports) in Korea (Republic) in 2013 and the Balance of Payment (as % of service exports) in Saudi Arabia in 2014?
Ensure brevity in your answer.  16.66. What is the difference between the Balance of Payment (as % of service exports) of Korea (Republic) in 2013 and the Balance of Payment (as % of service exports) of South Africa in 2014?
Offer a very short reply. 3.7. What is the difference between the Balance of Payment (as % of service exports) of Saudi Arabia in 2013 and the Balance of Payment (as % of service exports) of South Africa in 2014?
Offer a very short reply. -12.14. What is the average Balance of Payment (as % of service exports) in Bosnia and Herzegovina per year?
Give a very brief answer. 6.77. What is the average Balance of Payment (as % of service exports) of Korea (Republic) per year?
Your answer should be very brief. 17.46. What is the average Balance of Payment (as % of service exports) in Saudi Arabia per year?
Your answer should be compact. 8.68. What is the average Balance of Payment (as % of service exports) of South Africa per year?
Your response must be concise. 13.58. In the year 2007, what is the difference between the Balance of Payment (as % of service exports) in Bosnia and Herzegovina and Balance of Payment (as % of service exports) in Korea (Republic)?
Make the answer very short. -12.34. In the year 2007, what is the difference between the Balance of Payment (as % of service exports) in Bosnia and Herzegovina and Balance of Payment (as % of service exports) in Saudi Arabia?
Provide a short and direct response. -41.56. In the year 2007, what is the difference between the Balance of Payment (as % of service exports) of Bosnia and Herzegovina and Balance of Payment (as % of service exports) of South Africa?
Make the answer very short. -4.31. In the year 2007, what is the difference between the Balance of Payment (as % of service exports) of Korea (Republic) and Balance of Payment (as % of service exports) of Saudi Arabia?
Give a very brief answer. -29.22. In the year 2007, what is the difference between the Balance of Payment (as % of service exports) of Korea (Republic) and Balance of Payment (as % of service exports) of South Africa?
Your answer should be very brief. 8.03. In the year 2007, what is the difference between the Balance of Payment (as % of service exports) of Saudi Arabia and Balance of Payment (as % of service exports) of South Africa?
Ensure brevity in your answer.  37.25. In the year 2008, what is the difference between the Balance of Payment (as % of service exports) in Bosnia and Herzegovina and Balance of Payment (as % of service exports) in Korea (Republic)?
Ensure brevity in your answer.  -8.45. In the year 2008, what is the difference between the Balance of Payment (as % of service exports) in Bosnia and Herzegovina and Balance of Payment (as % of service exports) in Saudi Arabia?
Your response must be concise. 4.19. In the year 2008, what is the difference between the Balance of Payment (as % of service exports) of Bosnia and Herzegovina and Balance of Payment (as % of service exports) of South Africa?
Ensure brevity in your answer.  -5.05. In the year 2008, what is the difference between the Balance of Payment (as % of service exports) of Korea (Republic) and Balance of Payment (as % of service exports) of Saudi Arabia?
Your response must be concise. 12.64. In the year 2008, what is the difference between the Balance of Payment (as % of service exports) in Korea (Republic) and Balance of Payment (as % of service exports) in South Africa?
Provide a succinct answer. 3.4. In the year 2008, what is the difference between the Balance of Payment (as % of service exports) in Saudi Arabia and Balance of Payment (as % of service exports) in South Africa?
Make the answer very short. -9.24. In the year 2009, what is the difference between the Balance of Payment (as % of service exports) of Bosnia and Herzegovina and Balance of Payment (as % of service exports) of Korea (Republic)?
Give a very brief answer. -7.37. In the year 2009, what is the difference between the Balance of Payment (as % of service exports) of Bosnia and Herzegovina and Balance of Payment (as % of service exports) of Saudi Arabia?
Your answer should be very brief. 5.09. In the year 2009, what is the difference between the Balance of Payment (as % of service exports) of Bosnia and Herzegovina and Balance of Payment (as % of service exports) of South Africa?
Your answer should be very brief. -4.95. In the year 2009, what is the difference between the Balance of Payment (as % of service exports) of Korea (Republic) and Balance of Payment (as % of service exports) of Saudi Arabia?
Give a very brief answer. 12.46. In the year 2009, what is the difference between the Balance of Payment (as % of service exports) of Korea (Republic) and Balance of Payment (as % of service exports) of South Africa?
Provide a succinct answer. 2.42. In the year 2009, what is the difference between the Balance of Payment (as % of service exports) in Saudi Arabia and Balance of Payment (as % of service exports) in South Africa?
Your answer should be very brief. -10.04. In the year 2010, what is the difference between the Balance of Payment (as % of service exports) of Bosnia and Herzegovina and Balance of Payment (as % of service exports) of Korea (Republic)?
Make the answer very short. -7.83. In the year 2010, what is the difference between the Balance of Payment (as % of service exports) of Bosnia and Herzegovina and Balance of Payment (as % of service exports) of Saudi Arabia?
Keep it short and to the point. 4.02. In the year 2010, what is the difference between the Balance of Payment (as % of service exports) in Bosnia and Herzegovina and Balance of Payment (as % of service exports) in South Africa?
Your answer should be compact. -5.76. In the year 2010, what is the difference between the Balance of Payment (as % of service exports) in Korea (Republic) and Balance of Payment (as % of service exports) in Saudi Arabia?
Your answer should be compact. 11.85. In the year 2010, what is the difference between the Balance of Payment (as % of service exports) of Korea (Republic) and Balance of Payment (as % of service exports) of South Africa?
Offer a terse response. 2.07. In the year 2010, what is the difference between the Balance of Payment (as % of service exports) in Saudi Arabia and Balance of Payment (as % of service exports) in South Africa?
Your answer should be compact. -9.78. In the year 2011, what is the difference between the Balance of Payment (as % of service exports) in Bosnia and Herzegovina and Balance of Payment (as % of service exports) in Korea (Republic)?
Give a very brief answer. -9.01. In the year 2011, what is the difference between the Balance of Payment (as % of service exports) of Bosnia and Herzegovina and Balance of Payment (as % of service exports) of Saudi Arabia?
Offer a very short reply. 4.49. In the year 2011, what is the difference between the Balance of Payment (as % of service exports) in Bosnia and Herzegovina and Balance of Payment (as % of service exports) in South Africa?
Your answer should be very brief. -7.24. In the year 2011, what is the difference between the Balance of Payment (as % of service exports) of Korea (Republic) and Balance of Payment (as % of service exports) of Saudi Arabia?
Offer a very short reply. 13.49. In the year 2011, what is the difference between the Balance of Payment (as % of service exports) of Korea (Republic) and Balance of Payment (as % of service exports) of South Africa?
Offer a terse response. 1.77. In the year 2011, what is the difference between the Balance of Payment (as % of service exports) of Saudi Arabia and Balance of Payment (as % of service exports) of South Africa?
Offer a terse response. -11.72. In the year 2012, what is the difference between the Balance of Payment (as % of service exports) of Bosnia and Herzegovina and Balance of Payment (as % of service exports) of Korea (Republic)?
Offer a terse response. -10.88. In the year 2012, what is the difference between the Balance of Payment (as % of service exports) of Bosnia and Herzegovina and Balance of Payment (as % of service exports) of Saudi Arabia?
Provide a short and direct response. 2.74. In the year 2012, what is the difference between the Balance of Payment (as % of service exports) in Bosnia and Herzegovina and Balance of Payment (as % of service exports) in South Africa?
Provide a succinct answer. -8.16. In the year 2012, what is the difference between the Balance of Payment (as % of service exports) of Korea (Republic) and Balance of Payment (as % of service exports) of Saudi Arabia?
Ensure brevity in your answer.  13.62. In the year 2012, what is the difference between the Balance of Payment (as % of service exports) in Korea (Republic) and Balance of Payment (as % of service exports) in South Africa?
Make the answer very short. 2.72. In the year 2012, what is the difference between the Balance of Payment (as % of service exports) in Saudi Arabia and Balance of Payment (as % of service exports) in South Africa?
Your answer should be compact. -10.9. In the year 2013, what is the difference between the Balance of Payment (as % of service exports) in Bosnia and Herzegovina and Balance of Payment (as % of service exports) in Korea (Republic)?
Your answer should be compact. -13.06. In the year 2013, what is the difference between the Balance of Payment (as % of service exports) in Bosnia and Herzegovina and Balance of Payment (as % of service exports) in Saudi Arabia?
Provide a succinct answer. 2.78. In the year 2013, what is the difference between the Balance of Payment (as % of service exports) in Bosnia and Herzegovina and Balance of Payment (as % of service exports) in South Africa?
Offer a very short reply. -9.09. In the year 2013, what is the difference between the Balance of Payment (as % of service exports) in Korea (Republic) and Balance of Payment (as % of service exports) in Saudi Arabia?
Ensure brevity in your answer.  15.84. In the year 2013, what is the difference between the Balance of Payment (as % of service exports) of Korea (Republic) and Balance of Payment (as % of service exports) of South Africa?
Your answer should be very brief. 3.97. In the year 2013, what is the difference between the Balance of Payment (as % of service exports) of Saudi Arabia and Balance of Payment (as % of service exports) of South Africa?
Your response must be concise. -11.87. In the year 2014, what is the difference between the Balance of Payment (as % of service exports) of Bosnia and Herzegovina and Balance of Payment (as % of service exports) of Korea (Republic)?
Provide a short and direct response. -16.59. In the year 2014, what is the difference between the Balance of Payment (as % of service exports) of Bosnia and Herzegovina and Balance of Payment (as % of service exports) of Saudi Arabia?
Your response must be concise. 2.97. In the year 2014, what is the difference between the Balance of Payment (as % of service exports) in Bosnia and Herzegovina and Balance of Payment (as % of service exports) in South Africa?
Provide a short and direct response. -9.99. In the year 2014, what is the difference between the Balance of Payment (as % of service exports) in Korea (Republic) and Balance of Payment (as % of service exports) in Saudi Arabia?
Offer a very short reply. 19.56. In the year 2014, what is the difference between the Balance of Payment (as % of service exports) of Korea (Republic) and Balance of Payment (as % of service exports) of South Africa?
Your answer should be very brief. 6.6. In the year 2014, what is the difference between the Balance of Payment (as % of service exports) in Saudi Arabia and Balance of Payment (as % of service exports) in South Africa?
Keep it short and to the point. -12.96. What is the ratio of the Balance of Payment (as % of service exports) in Bosnia and Herzegovina in 2007 to that in 2008?
Make the answer very short. 0.99. What is the ratio of the Balance of Payment (as % of service exports) of Korea (Republic) in 2007 to that in 2008?
Give a very brief answer. 1.25. What is the ratio of the Balance of Payment (as % of service exports) of Saudi Arabia in 2007 to that in 2008?
Ensure brevity in your answer.  17.69. What is the ratio of the Balance of Payment (as % of service exports) in Bosnia and Herzegovina in 2007 to that in 2009?
Make the answer very short. 0.88. What is the ratio of the Balance of Payment (as % of service exports) of Korea (Republic) in 2007 to that in 2009?
Keep it short and to the point. 1.27. What is the ratio of the Balance of Payment (as % of service exports) in Saudi Arabia in 2007 to that in 2009?
Offer a very short reply. 18.02. What is the ratio of the Balance of Payment (as % of service exports) in South Africa in 2007 to that in 2009?
Make the answer very short. 0.88. What is the ratio of the Balance of Payment (as % of service exports) in Bosnia and Herzegovina in 2007 to that in 2010?
Keep it short and to the point. 0.92. What is the ratio of the Balance of Payment (as % of service exports) of Korea (Republic) in 2007 to that in 2010?
Offer a very short reply. 1.26. What is the ratio of the Balance of Payment (as % of service exports) in Saudi Arabia in 2007 to that in 2010?
Offer a very short reply. 14.29. What is the ratio of the Balance of Payment (as % of service exports) in South Africa in 2007 to that in 2010?
Keep it short and to the point. 0.85. What is the ratio of the Balance of Payment (as % of service exports) in Bosnia and Herzegovina in 2007 to that in 2011?
Make the answer very short. 0.92. What is the ratio of the Balance of Payment (as % of service exports) of Korea (Republic) in 2007 to that in 2011?
Provide a succinct answer. 1.17. What is the ratio of the Balance of Payment (as % of service exports) of Saudi Arabia in 2007 to that in 2011?
Make the answer very short. 16.59. What is the ratio of the Balance of Payment (as % of service exports) in South Africa in 2007 to that in 2011?
Offer a very short reply. 0.76. What is the ratio of the Balance of Payment (as % of service exports) of Bosnia and Herzegovina in 2007 to that in 2012?
Ensure brevity in your answer.  1.08. What is the ratio of the Balance of Payment (as % of service exports) in Korea (Republic) in 2007 to that in 2012?
Your answer should be compact. 1.11. What is the ratio of the Balance of Payment (as % of service exports) in Saudi Arabia in 2007 to that in 2012?
Your answer should be very brief. 13.48. What is the ratio of the Balance of Payment (as % of service exports) of South Africa in 2007 to that in 2012?
Give a very brief answer. 0.77. What is the ratio of the Balance of Payment (as % of service exports) in Bosnia and Herzegovina in 2007 to that in 2013?
Provide a short and direct response. 1.13. What is the ratio of the Balance of Payment (as % of service exports) in Saudi Arabia in 2007 to that in 2013?
Provide a short and direct response. 14.82. What is the ratio of the Balance of Payment (as % of service exports) in South Africa in 2007 to that in 2013?
Offer a very short reply. 0.74. What is the ratio of the Balance of Payment (as % of service exports) of Bosnia and Herzegovina in 2007 to that in 2014?
Make the answer very short. 1.26. What is the ratio of the Balance of Payment (as % of service exports) of Korea (Republic) in 2007 to that in 2014?
Ensure brevity in your answer.  0.87. What is the ratio of the Balance of Payment (as % of service exports) in Saudi Arabia in 2007 to that in 2014?
Ensure brevity in your answer.  19.79. What is the ratio of the Balance of Payment (as % of service exports) in South Africa in 2007 to that in 2014?
Offer a terse response. 0.72. What is the ratio of the Balance of Payment (as % of service exports) in Bosnia and Herzegovina in 2008 to that in 2009?
Provide a succinct answer. 0.89. What is the ratio of the Balance of Payment (as % of service exports) in Korea (Republic) in 2008 to that in 2009?
Make the answer very short. 1.01. What is the ratio of the Balance of Payment (as % of service exports) in Saudi Arabia in 2008 to that in 2009?
Provide a succinct answer. 1.02. What is the ratio of the Balance of Payment (as % of service exports) in South Africa in 2008 to that in 2009?
Your answer should be very brief. 0.94. What is the ratio of the Balance of Payment (as % of service exports) in Bosnia and Herzegovina in 2008 to that in 2010?
Your response must be concise. 0.93. What is the ratio of the Balance of Payment (as % of service exports) of Korea (Republic) in 2008 to that in 2010?
Give a very brief answer. 1.01. What is the ratio of the Balance of Payment (as % of service exports) of Saudi Arabia in 2008 to that in 2010?
Your answer should be very brief. 0.81. What is the ratio of the Balance of Payment (as % of service exports) of South Africa in 2008 to that in 2010?
Offer a terse response. 0.91. What is the ratio of the Balance of Payment (as % of service exports) of Bosnia and Herzegovina in 2008 to that in 2011?
Make the answer very short. 0.93. What is the ratio of the Balance of Payment (as % of service exports) in Korea (Republic) in 2008 to that in 2011?
Keep it short and to the point. 0.94. What is the ratio of the Balance of Payment (as % of service exports) in Saudi Arabia in 2008 to that in 2011?
Keep it short and to the point. 0.94. What is the ratio of the Balance of Payment (as % of service exports) in South Africa in 2008 to that in 2011?
Keep it short and to the point. 0.82. What is the ratio of the Balance of Payment (as % of service exports) of Bosnia and Herzegovina in 2008 to that in 2012?
Provide a succinct answer. 1.09. What is the ratio of the Balance of Payment (as % of service exports) of Korea (Republic) in 2008 to that in 2012?
Your answer should be compact. 0.89. What is the ratio of the Balance of Payment (as % of service exports) of Saudi Arabia in 2008 to that in 2012?
Offer a very short reply. 0.76. What is the ratio of the Balance of Payment (as % of service exports) in South Africa in 2008 to that in 2012?
Keep it short and to the point. 0.83. What is the ratio of the Balance of Payment (as % of service exports) of Bosnia and Herzegovina in 2008 to that in 2013?
Provide a short and direct response. 1.14. What is the ratio of the Balance of Payment (as % of service exports) of Korea (Republic) in 2008 to that in 2013?
Your answer should be compact. 0.8. What is the ratio of the Balance of Payment (as % of service exports) in Saudi Arabia in 2008 to that in 2013?
Offer a very short reply. 0.84. What is the ratio of the Balance of Payment (as % of service exports) of South Africa in 2008 to that in 2013?
Offer a terse response. 0.79. What is the ratio of the Balance of Payment (as % of service exports) in Bosnia and Herzegovina in 2008 to that in 2014?
Your response must be concise. 1.28. What is the ratio of the Balance of Payment (as % of service exports) of Korea (Republic) in 2008 to that in 2014?
Provide a succinct answer. 0.7. What is the ratio of the Balance of Payment (as % of service exports) of Saudi Arabia in 2008 to that in 2014?
Offer a very short reply. 1.12. What is the ratio of the Balance of Payment (as % of service exports) of South Africa in 2008 to that in 2014?
Provide a succinct answer. 0.78. What is the ratio of the Balance of Payment (as % of service exports) in Bosnia and Herzegovina in 2009 to that in 2010?
Provide a succinct answer. 1.05. What is the ratio of the Balance of Payment (as % of service exports) of Saudi Arabia in 2009 to that in 2010?
Provide a succinct answer. 0.79. What is the ratio of the Balance of Payment (as % of service exports) in South Africa in 2009 to that in 2010?
Offer a terse response. 0.97. What is the ratio of the Balance of Payment (as % of service exports) in Bosnia and Herzegovina in 2009 to that in 2011?
Offer a very short reply. 1.05. What is the ratio of the Balance of Payment (as % of service exports) of Saudi Arabia in 2009 to that in 2011?
Provide a succinct answer. 0.92. What is the ratio of the Balance of Payment (as % of service exports) of South Africa in 2009 to that in 2011?
Ensure brevity in your answer.  0.87. What is the ratio of the Balance of Payment (as % of service exports) in Bosnia and Herzegovina in 2009 to that in 2012?
Ensure brevity in your answer.  1.23. What is the ratio of the Balance of Payment (as % of service exports) of Korea (Republic) in 2009 to that in 2012?
Give a very brief answer. 0.88. What is the ratio of the Balance of Payment (as % of service exports) of Saudi Arabia in 2009 to that in 2012?
Your answer should be compact. 0.75. What is the ratio of the Balance of Payment (as % of service exports) in South Africa in 2009 to that in 2012?
Provide a short and direct response. 0.88. What is the ratio of the Balance of Payment (as % of service exports) of Bosnia and Herzegovina in 2009 to that in 2013?
Give a very brief answer. 1.29. What is the ratio of the Balance of Payment (as % of service exports) in Korea (Republic) in 2009 to that in 2013?
Your answer should be compact. 0.79. What is the ratio of the Balance of Payment (as % of service exports) of Saudi Arabia in 2009 to that in 2013?
Your answer should be compact. 0.82. What is the ratio of the Balance of Payment (as % of service exports) of South Africa in 2009 to that in 2013?
Keep it short and to the point. 0.84. What is the ratio of the Balance of Payment (as % of service exports) in Bosnia and Herzegovina in 2009 to that in 2014?
Your answer should be compact. 1.44. What is the ratio of the Balance of Payment (as % of service exports) of Korea (Republic) in 2009 to that in 2014?
Provide a short and direct response. 0.69. What is the ratio of the Balance of Payment (as % of service exports) in Saudi Arabia in 2009 to that in 2014?
Ensure brevity in your answer.  1.1. What is the ratio of the Balance of Payment (as % of service exports) of South Africa in 2009 to that in 2014?
Make the answer very short. 0.83. What is the ratio of the Balance of Payment (as % of service exports) in Korea (Republic) in 2010 to that in 2011?
Offer a very short reply. 0.93. What is the ratio of the Balance of Payment (as % of service exports) of Saudi Arabia in 2010 to that in 2011?
Your answer should be very brief. 1.16. What is the ratio of the Balance of Payment (as % of service exports) of South Africa in 2010 to that in 2011?
Provide a succinct answer. 0.9. What is the ratio of the Balance of Payment (as % of service exports) in Bosnia and Herzegovina in 2010 to that in 2012?
Your response must be concise. 1.17. What is the ratio of the Balance of Payment (as % of service exports) of Korea (Republic) in 2010 to that in 2012?
Provide a short and direct response. 0.89. What is the ratio of the Balance of Payment (as % of service exports) of Saudi Arabia in 2010 to that in 2012?
Ensure brevity in your answer.  0.94. What is the ratio of the Balance of Payment (as % of service exports) in South Africa in 2010 to that in 2012?
Give a very brief answer. 0.91. What is the ratio of the Balance of Payment (as % of service exports) of Bosnia and Herzegovina in 2010 to that in 2013?
Make the answer very short. 1.22. What is the ratio of the Balance of Payment (as % of service exports) of Korea (Republic) in 2010 to that in 2013?
Provide a short and direct response. 0.8. What is the ratio of the Balance of Payment (as % of service exports) of Saudi Arabia in 2010 to that in 2013?
Keep it short and to the point. 1.04. What is the ratio of the Balance of Payment (as % of service exports) in South Africa in 2010 to that in 2013?
Ensure brevity in your answer.  0.87. What is the ratio of the Balance of Payment (as % of service exports) of Bosnia and Herzegovina in 2010 to that in 2014?
Ensure brevity in your answer.  1.37. What is the ratio of the Balance of Payment (as % of service exports) of Korea (Republic) in 2010 to that in 2014?
Keep it short and to the point. 0.69. What is the ratio of the Balance of Payment (as % of service exports) of Saudi Arabia in 2010 to that in 2014?
Your response must be concise. 1.39. What is the ratio of the Balance of Payment (as % of service exports) in South Africa in 2010 to that in 2014?
Provide a short and direct response. 0.85. What is the ratio of the Balance of Payment (as % of service exports) of Bosnia and Herzegovina in 2011 to that in 2012?
Keep it short and to the point. 1.17. What is the ratio of the Balance of Payment (as % of service exports) in Korea (Republic) in 2011 to that in 2012?
Keep it short and to the point. 0.95. What is the ratio of the Balance of Payment (as % of service exports) in Saudi Arabia in 2011 to that in 2012?
Offer a terse response. 0.81. What is the ratio of the Balance of Payment (as % of service exports) of South Africa in 2011 to that in 2012?
Provide a succinct answer. 1.01. What is the ratio of the Balance of Payment (as % of service exports) of Bosnia and Herzegovina in 2011 to that in 2013?
Offer a terse response. 1.22. What is the ratio of the Balance of Payment (as % of service exports) of Korea (Republic) in 2011 to that in 2013?
Offer a very short reply. 0.86. What is the ratio of the Balance of Payment (as % of service exports) in Saudi Arabia in 2011 to that in 2013?
Your response must be concise. 0.89. What is the ratio of the Balance of Payment (as % of service exports) in South Africa in 2011 to that in 2013?
Provide a short and direct response. 0.97. What is the ratio of the Balance of Payment (as % of service exports) of Bosnia and Herzegovina in 2011 to that in 2014?
Ensure brevity in your answer.  1.37. What is the ratio of the Balance of Payment (as % of service exports) of Korea (Republic) in 2011 to that in 2014?
Your answer should be compact. 0.75. What is the ratio of the Balance of Payment (as % of service exports) in Saudi Arabia in 2011 to that in 2014?
Provide a short and direct response. 1.19. What is the ratio of the Balance of Payment (as % of service exports) of South Africa in 2011 to that in 2014?
Offer a terse response. 0.95. What is the ratio of the Balance of Payment (as % of service exports) in Bosnia and Herzegovina in 2012 to that in 2013?
Ensure brevity in your answer.  1.05. What is the ratio of the Balance of Payment (as % of service exports) of Korea (Republic) in 2012 to that in 2013?
Offer a terse response. 0.9. What is the ratio of the Balance of Payment (as % of service exports) in Saudi Arabia in 2012 to that in 2013?
Provide a succinct answer. 1.1. What is the ratio of the Balance of Payment (as % of service exports) in South Africa in 2012 to that in 2013?
Offer a terse response. 0.96. What is the ratio of the Balance of Payment (as % of service exports) of Bosnia and Herzegovina in 2012 to that in 2014?
Provide a short and direct response. 1.17. What is the ratio of the Balance of Payment (as % of service exports) in Korea (Republic) in 2012 to that in 2014?
Your answer should be very brief. 0.78. What is the ratio of the Balance of Payment (as % of service exports) of Saudi Arabia in 2012 to that in 2014?
Offer a very short reply. 1.47. What is the ratio of the Balance of Payment (as % of service exports) of South Africa in 2012 to that in 2014?
Offer a terse response. 0.94. What is the ratio of the Balance of Payment (as % of service exports) of Bosnia and Herzegovina in 2013 to that in 2014?
Keep it short and to the point. 1.12. What is the ratio of the Balance of Payment (as % of service exports) of Korea (Republic) in 2013 to that in 2014?
Provide a short and direct response. 0.87. What is the ratio of the Balance of Payment (as % of service exports) in Saudi Arabia in 2013 to that in 2014?
Offer a very short reply. 1.34. What is the ratio of the Balance of Payment (as % of service exports) of South Africa in 2013 to that in 2014?
Ensure brevity in your answer.  0.98. What is the difference between the highest and the second highest Balance of Payment (as % of service exports) in Bosnia and Herzegovina?
Provide a short and direct response. 0.37. What is the difference between the highest and the second highest Balance of Payment (as % of service exports) of Korea (Republic)?
Offer a terse response. 2.84. What is the difference between the highest and the second highest Balance of Payment (as % of service exports) of Saudi Arabia?
Provide a succinct answer. 44.79. What is the difference between the highest and the second highest Balance of Payment (as % of service exports) of South Africa?
Your response must be concise. 0.27. What is the difference between the highest and the lowest Balance of Payment (as % of service exports) in Bosnia and Herzegovina?
Your answer should be very brief. 2.36. What is the difference between the highest and the lowest Balance of Payment (as % of service exports) of Korea (Republic)?
Give a very brief answer. 6.86. What is the difference between the highest and the lowest Balance of Payment (as % of service exports) in Saudi Arabia?
Give a very brief answer. 45.94. What is the difference between the highest and the lowest Balance of Payment (as % of service exports) of South Africa?
Give a very brief answer. 4.27. 